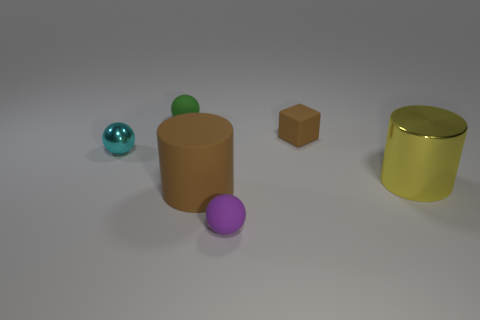Add 1 shiny balls. How many objects exist? 7 Subtract all blocks. How many objects are left? 5 Add 6 large brown objects. How many large brown objects are left? 7 Add 4 big gray matte blocks. How many big gray matte blocks exist? 4 Subtract 0 gray cylinders. How many objects are left? 6 Subtract all big gray shiny spheres. Subtract all small purple things. How many objects are left? 5 